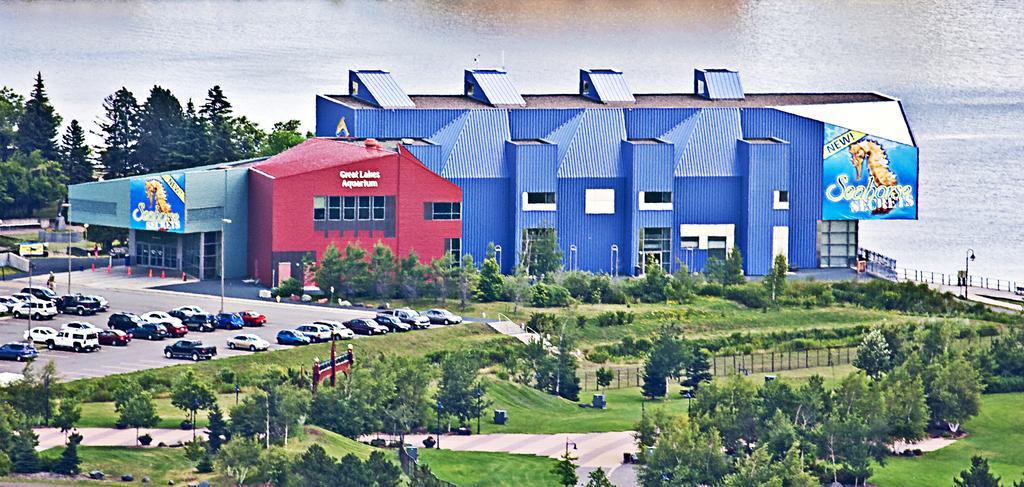How would you summarize this image in a sentence or two? In this image there are some trees at bottom of this image and left side of this image as well. there are some cars at middle left side of this image and there is a building in middle of this image. There is a sea at top of this image. 